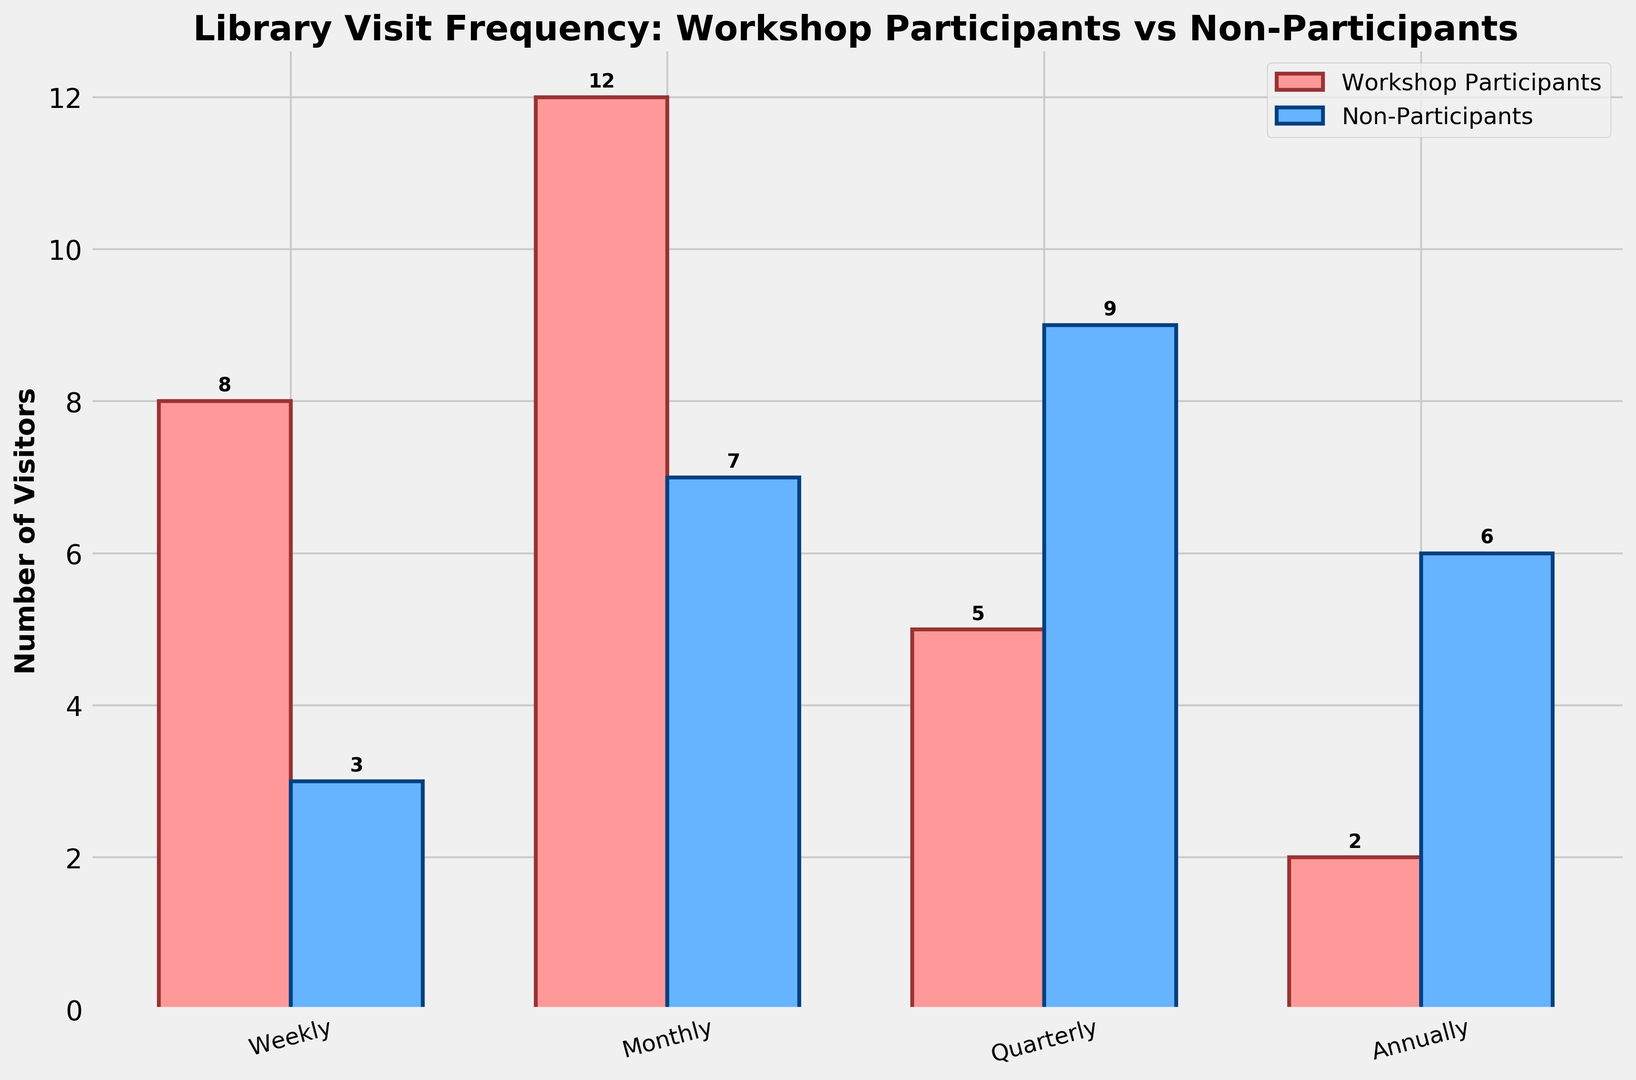What is the difference in the number of weekly visits between workshop participants and non-participants? Workshop participants have 8 weekly visits, while non-participants have 3. The difference is 8 - 3 = 5.
Answer: 5 Which group has a higher number of monthly visits? Workshop participants have 12 monthly visits, while non-participants have 7. Since 12 is greater than 7, workshop participants have a higher number of monthly visits.
Answer: Workshop participants How many annual visits are there in total for both groups? Workshop participants have 2 annual visits, and non-participants have 6. The total is 2 + 6 = 8.
Answer: 8 What is the average number of quarterly visits per group? Quarterly visits are 5 for workshop participants and 9 for non-participants, so the average for workshop participants is 5/1 = 5, and for non-participants, it is 9.0/1 = 9.0.
Answer: Workshop Participants: 5, Non-Participants: 9 Do workshop participants or non-participants have more evenly distributed visit frequencies? Workshop participants have visits distribution as [8, 12, 5, 2] while non-participants have [3, 7, 9, 6]. Non-participants seem to have a more balanced distribution since their bars are more consistent across all frequencies.
Answer: Non-participants Compare the number of visits that are quarterly and less frequent between the two groups. For quarterly and annually, participants have 5 + 2 = 7 and non-participants have 9 + 6 = 15. Non-participants have more visits that are quarterly and less frequent.
Answer: Non-participants Among all visit frequencies, which group has the highest single frequency visit count and what is the value? Workshop participants have the highest single frequency visit count with 12 monthly visits.
Answer: Workshop participants, 12 What is the total number of visits for workshop participants across all frequencies? The sum of all visits for workshop participants is 8 + 12 + 5 + 2 = 27.
Answer: 27 Which frequency category has the smallest difference in visits between the two groups? The differences are Weekly: 5, Monthly: 5, Quarterly: 4, Annually: 4. The smallest difference is in the Quarterly and Annually categories with a difference of 4 each.
Answer: Quarterly and Annually 